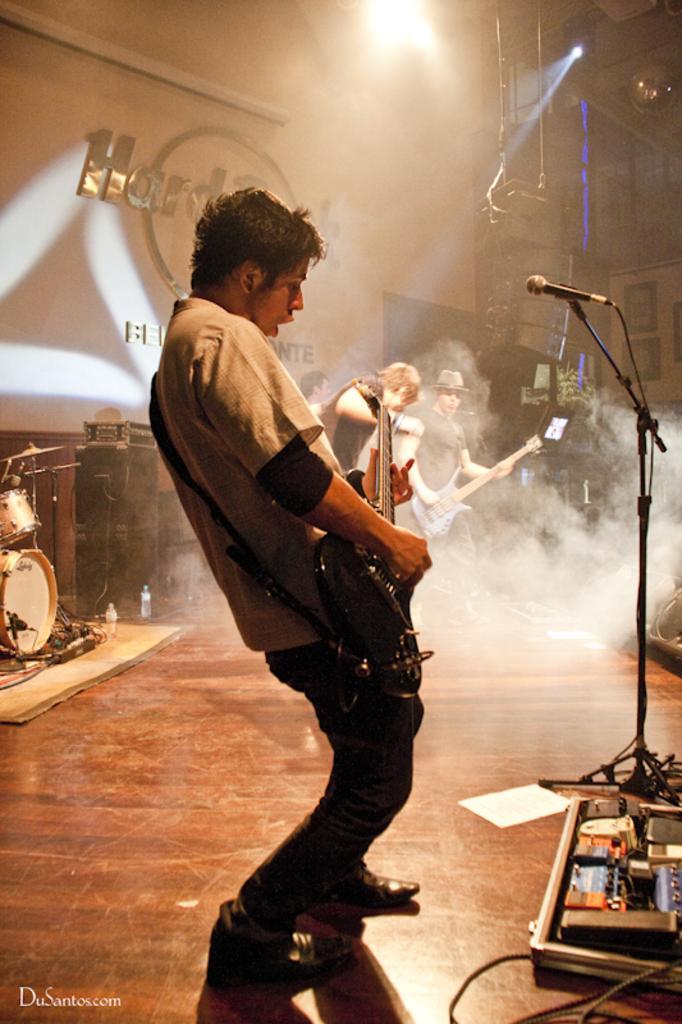In one or two sentences, can you explain what this image depicts? This image is taken indoors. At the bottom of the image there is a floor. In the background there is a wall. There is a text on the wall. There are a few picture frames on the wall. Three men are standing on the floor and they are playing music with musical instruments. On the left side of the image there are a few musical instruments on the floor. On the right side of the image there is smoke and there is a speaker box on the floor. There is a mic. There are a few instruments on the floor. In the middle of the image a boy is standing on the floor and playing music with a guitar. At the top of the image there is a light. 